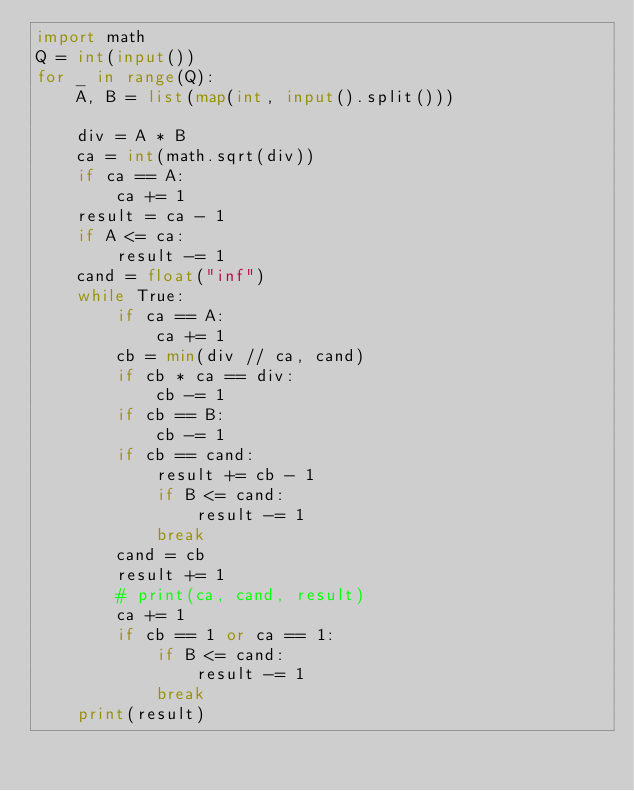Convert code to text. <code><loc_0><loc_0><loc_500><loc_500><_Python_>import math
Q = int(input())
for _ in range(Q):
    A, B = list(map(int, input().split()))

    div = A * B
    ca = int(math.sqrt(div))
    if ca == A:
        ca += 1
    result = ca - 1
    if A <= ca:
        result -= 1
    cand = float("inf")
    while True:
        if ca == A:
            ca += 1
        cb = min(div // ca, cand)
        if cb * ca == div:
            cb -= 1
        if cb == B:
            cb -= 1
        if cb == cand:
            result += cb - 1
            if B <= cand:
                result -= 1
            break
        cand = cb
        result += 1
        # print(ca, cand, result)
        ca += 1
        if cb == 1 or ca == 1:
            if B <= cand:
                result -= 1
            break
    print(result)
</code> 